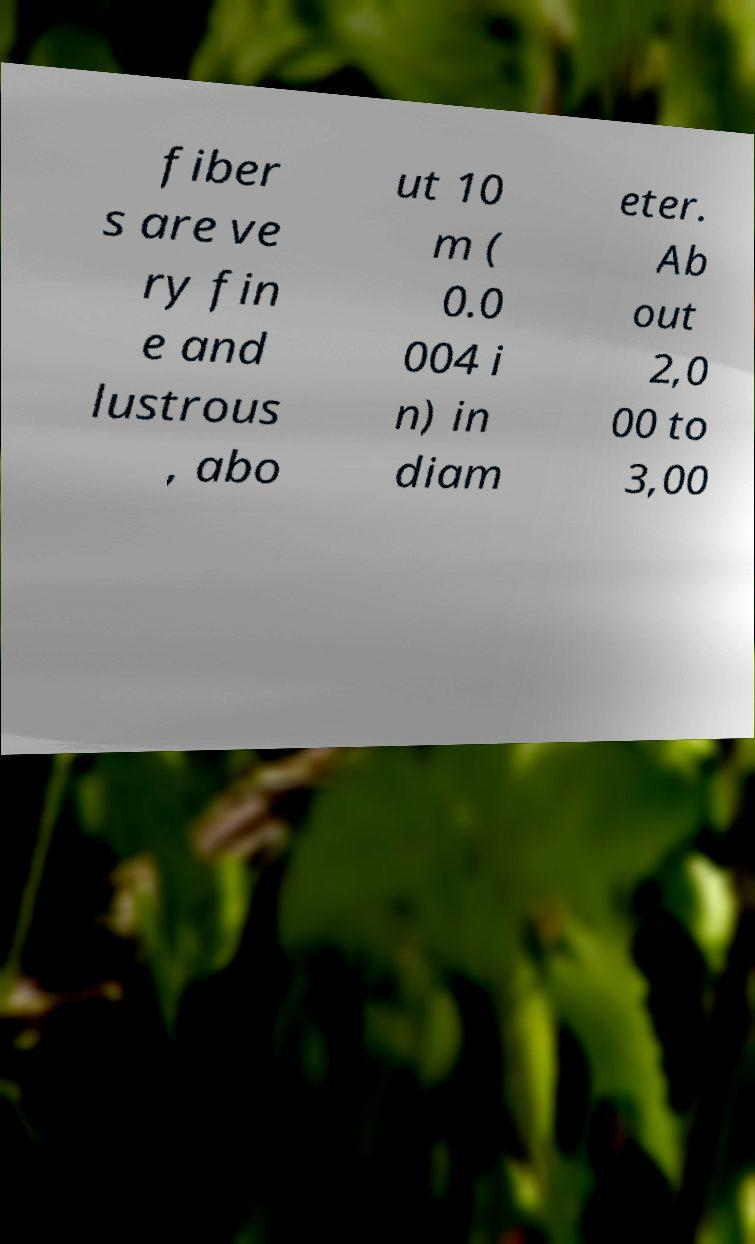Can you read and provide the text displayed in the image?This photo seems to have some interesting text. Can you extract and type it out for me? fiber s are ve ry fin e and lustrous , abo ut 10 m ( 0.0 004 i n) in diam eter. Ab out 2,0 00 to 3,00 